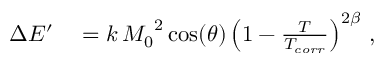<formula> <loc_0><loc_0><loc_500><loc_500>\begin{array} { r l } { \Delta E ^ { \prime } } & = k \, { M _ { 0 } } ^ { 2 } \cos ( \theta ) \left ( 1 - \frac { T } { T _ { c o r r } } \right ) ^ { 2 \beta } \, , } \end{array}</formula> 